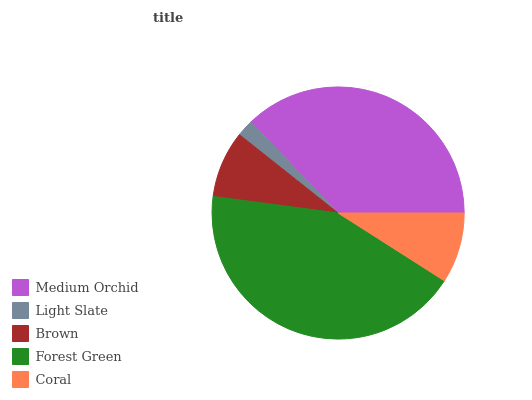Is Light Slate the minimum?
Answer yes or no. Yes. Is Forest Green the maximum?
Answer yes or no. Yes. Is Brown the minimum?
Answer yes or no. No. Is Brown the maximum?
Answer yes or no. No. Is Brown greater than Light Slate?
Answer yes or no. Yes. Is Light Slate less than Brown?
Answer yes or no. Yes. Is Light Slate greater than Brown?
Answer yes or no. No. Is Brown less than Light Slate?
Answer yes or no. No. Is Coral the high median?
Answer yes or no. Yes. Is Coral the low median?
Answer yes or no. Yes. Is Light Slate the high median?
Answer yes or no. No. Is Brown the low median?
Answer yes or no. No. 